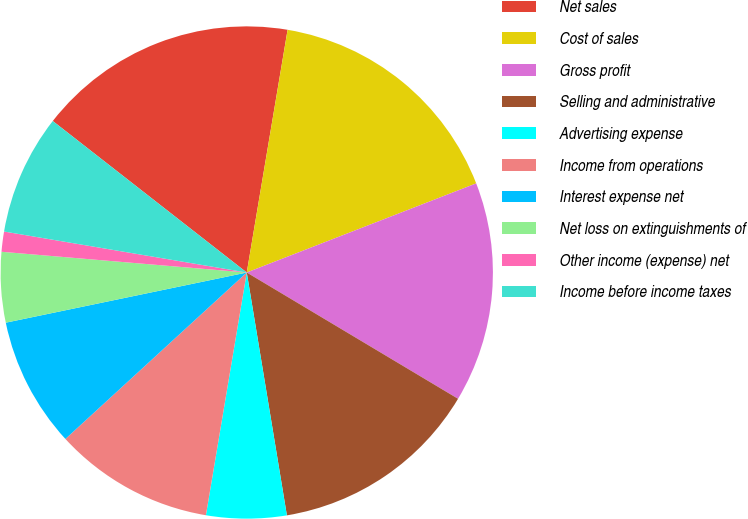<chart> <loc_0><loc_0><loc_500><loc_500><pie_chart><fcel>Net sales<fcel>Cost of sales<fcel>Gross profit<fcel>Selling and administrative<fcel>Advertising expense<fcel>Income from operations<fcel>Interest expense net<fcel>Net loss on extinguishments of<fcel>Other income (expense) net<fcel>Income before income taxes<nl><fcel>17.1%<fcel>16.45%<fcel>14.47%<fcel>13.82%<fcel>5.26%<fcel>10.53%<fcel>8.55%<fcel>4.61%<fcel>1.32%<fcel>7.89%<nl></chart> 